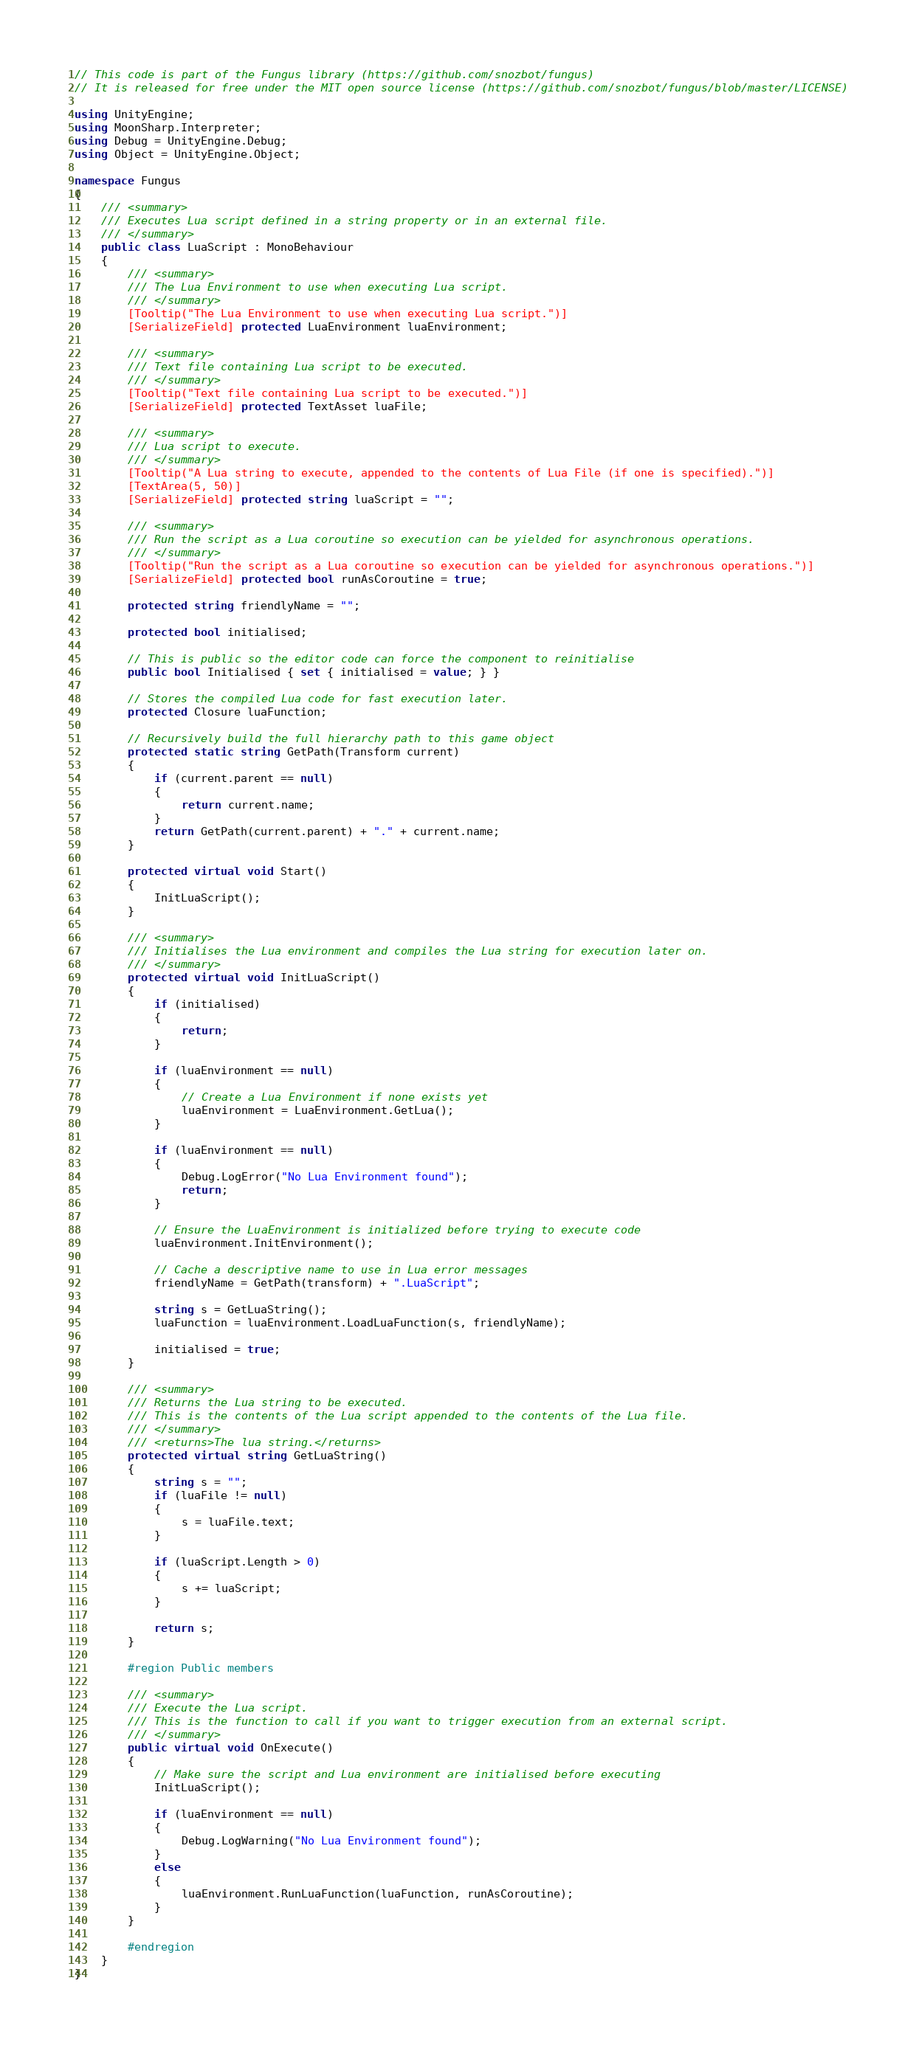Convert code to text. <code><loc_0><loc_0><loc_500><loc_500><_C#_>// This code is part of the Fungus library (https://github.com/snozbot/fungus)
// It is released for free under the MIT open source license (https://github.com/snozbot/fungus/blob/master/LICENSE)

using UnityEngine;
using MoonSharp.Interpreter;
using Debug = UnityEngine.Debug;
using Object = UnityEngine.Object;

namespace Fungus
{
    /// <summary>
    /// Executes Lua script defined in a string property or in an external file.
    /// </summary>
    public class LuaScript : MonoBehaviour
    {
        /// <summary>
        /// The Lua Environment to use when executing Lua script.
        /// </summary>
        [Tooltip("The Lua Environment to use when executing Lua script.")]
        [SerializeField] protected LuaEnvironment luaEnvironment;

        /// <summary>
        /// Text file containing Lua script to be executed.
        /// </summary>
        [Tooltip("Text file containing Lua script to be executed.")]
        [SerializeField] protected TextAsset luaFile;

        /// <summary>
        /// Lua script to execute.
        /// </summary>
        [Tooltip("A Lua string to execute, appended to the contents of Lua File (if one is specified).")]
        [TextArea(5, 50)]
        [SerializeField] protected string luaScript = "";

        /// <summary>
        /// Run the script as a Lua coroutine so execution can be yielded for asynchronous operations.
        /// </summary>
        [Tooltip("Run the script as a Lua coroutine so execution can be yielded for asynchronous operations.")]
        [SerializeField] protected bool runAsCoroutine = true;

        protected string friendlyName = "";

        protected bool initialised;

        // This is public so the editor code can force the component to reinitialise
        public bool Initialised { set { initialised = value; } }

        // Stores the compiled Lua code for fast execution later.
        protected Closure luaFunction;

        // Recursively build the full hierarchy path to this game object
        protected static string GetPath(Transform current) 
        {
            if (current.parent == null)
            {
                return current.name;
            }
            return GetPath(current.parent) + "." + current.name;
        }

        protected virtual void Start()
        {
            InitLuaScript();
        }

        /// <summary>
        /// Initialises the Lua environment and compiles the Lua string for execution later on.
        /// </summary>
        protected virtual void InitLuaScript()
        {
            if (initialised)
            {
                return;
            }

            if (luaEnvironment == null)        
            {
                // Create a Lua Environment if none exists yet
                luaEnvironment = LuaEnvironment.GetLua();
            }

            if (luaEnvironment == null)        
            {
                Debug.LogError("No Lua Environment found");
                return;
            }

            // Ensure the LuaEnvironment is initialized before trying to execute code
            luaEnvironment.InitEnvironment();

            // Cache a descriptive name to use in Lua error messages
            friendlyName = GetPath(transform) + ".LuaScript";

            string s = GetLuaString();
            luaFunction = luaEnvironment.LoadLuaFunction(s, friendlyName);

            initialised = true;
        }

        /// <summary>
        /// Returns the Lua string to be executed. 
        /// This is the contents of the Lua script appended to the contents of the Lua file.
        /// </summary>
        /// <returns>The lua string.</returns>
        protected virtual string GetLuaString()
        {
            string s = "";
            if (luaFile != null)
            {
                s = luaFile.text;
            }

            if (luaScript.Length > 0)
            {
                s += luaScript;
            }

            return s;
        }

        #region Public members

        /// <summary>
        /// Execute the Lua script.
        /// This is the function to call if you want to trigger execution from an external script.
        /// </summary>
        public virtual void OnExecute()
        {
            // Make sure the script and Lua environment are initialised before executing
            InitLuaScript();

            if (luaEnvironment == null)
            {
                Debug.LogWarning("No Lua Environment found");
            }
            else
            {
                luaEnvironment.RunLuaFunction(luaFunction, runAsCoroutine);
            }
        }

        #endregion
    }
}
</code> 